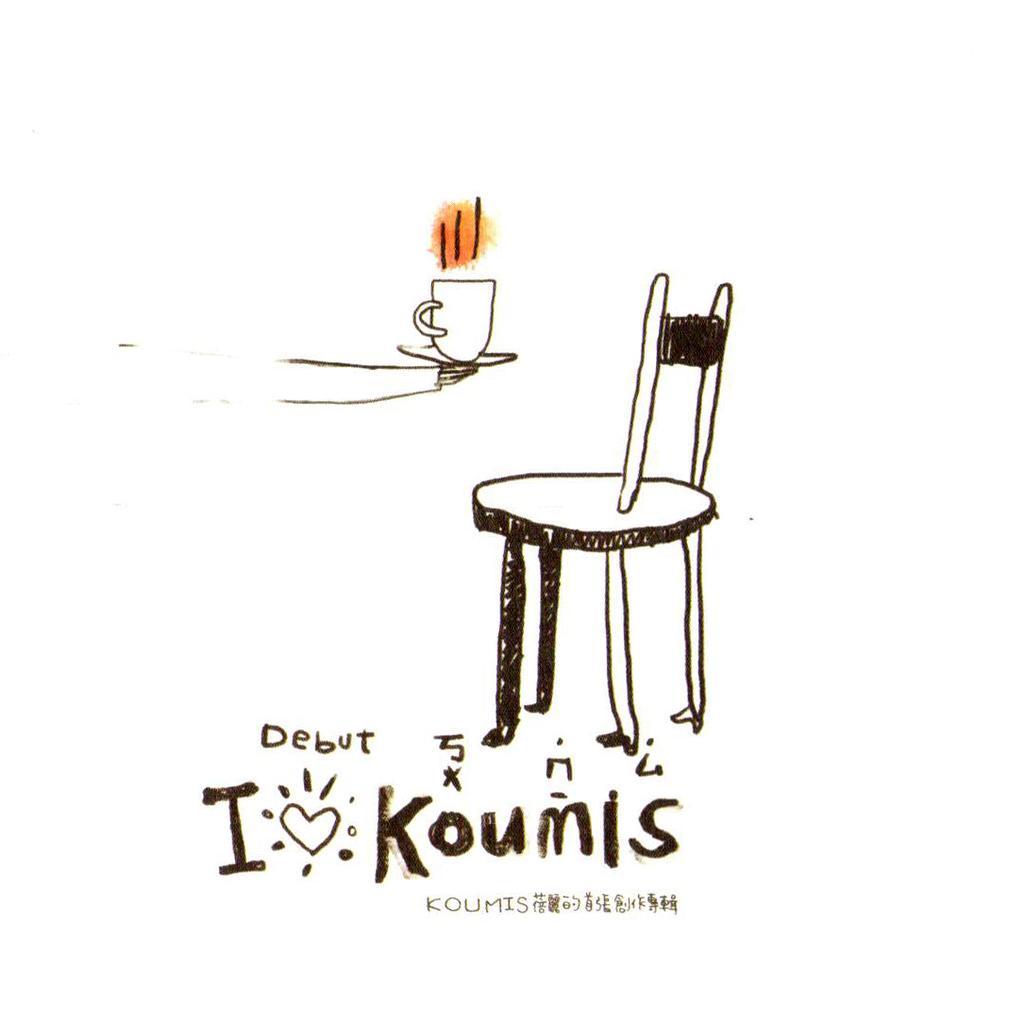Describe this image in one or two sentences. This picture is a cartoon sketch, where there is a chair and a person's hand holding a cup in his hand and text written on it as" debut GIAKOUMIS". 